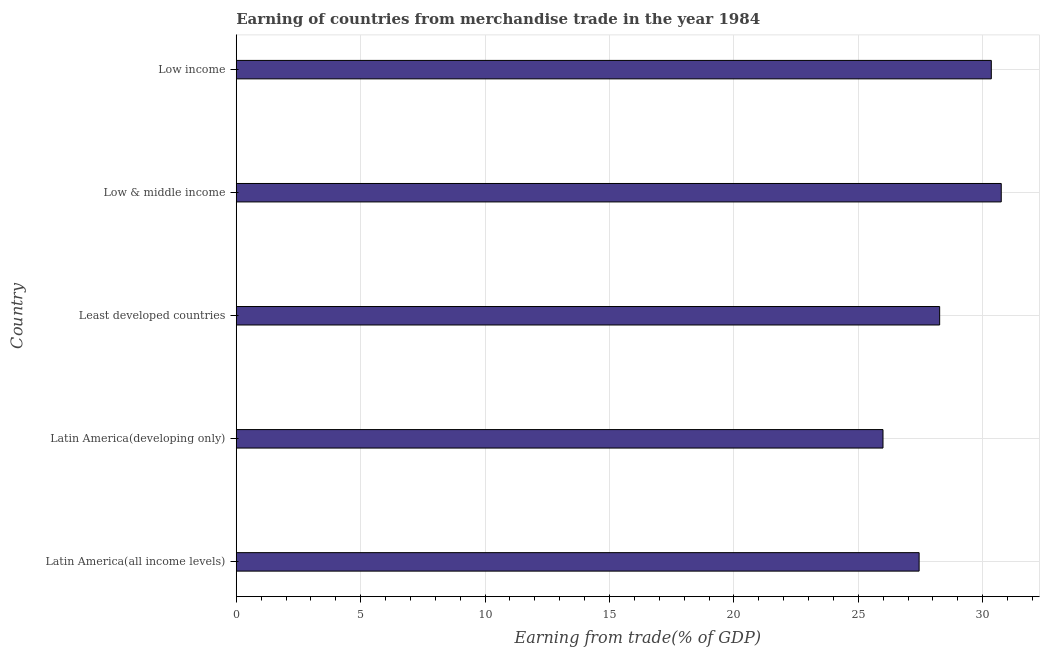What is the title of the graph?
Offer a terse response. Earning of countries from merchandise trade in the year 1984. What is the label or title of the X-axis?
Provide a succinct answer. Earning from trade(% of GDP). What is the label or title of the Y-axis?
Provide a succinct answer. Country. What is the earning from merchandise trade in Least developed countries?
Provide a short and direct response. 28.27. Across all countries, what is the maximum earning from merchandise trade?
Provide a succinct answer. 30.74. Across all countries, what is the minimum earning from merchandise trade?
Your answer should be very brief. 25.99. In which country was the earning from merchandise trade maximum?
Make the answer very short. Low & middle income. In which country was the earning from merchandise trade minimum?
Ensure brevity in your answer.  Latin America(developing only). What is the sum of the earning from merchandise trade?
Provide a succinct answer. 142.79. What is the difference between the earning from merchandise trade in Latin America(all income levels) and Latin America(developing only)?
Make the answer very short. 1.45. What is the average earning from merchandise trade per country?
Your answer should be compact. 28.56. What is the median earning from merchandise trade?
Your answer should be very brief. 28.27. In how many countries, is the earning from merchandise trade greater than 18 %?
Your response must be concise. 5. What is the ratio of the earning from merchandise trade in Least developed countries to that in Low & middle income?
Give a very brief answer. 0.92. What is the difference between the highest and the second highest earning from merchandise trade?
Your answer should be compact. 0.4. What is the difference between the highest and the lowest earning from merchandise trade?
Your answer should be very brief. 4.75. How many countries are there in the graph?
Give a very brief answer. 5. What is the difference between two consecutive major ticks on the X-axis?
Offer a very short reply. 5. What is the Earning from trade(% of GDP) of Latin America(all income levels)?
Make the answer very short. 27.44. What is the Earning from trade(% of GDP) in Latin America(developing only)?
Give a very brief answer. 25.99. What is the Earning from trade(% of GDP) in Least developed countries?
Your response must be concise. 28.27. What is the Earning from trade(% of GDP) of Low & middle income?
Ensure brevity in your answer.  30.74. What is the Earning from trade(% of GDP) of Low income?
Provide a short and direct response. 30.34. What is the difference between the Earning from trade(% of GDP) in Latin America(all income levels) and Latin America(developing only)?
Keep it short and to the point. 1.45. What is the difference between the Earning from trade(% of GDP) in Latin America(all income levels) and Least developed countries?
Your answer should be compact. -0.82. What is the difference between the Earning from trade(% of GDP) in Latin America(all income levels) and Low & middle income?
Keep it short and to the point. -3.3. What is the difference between the Earning from trade(% of GDP) in Latin America(all income levels) and Low income?
Your answer should be compact. -2.9. What is the difference between the Earning from trade(% of GDP) in Latin America(developing only) and Least developed countries?
Offer a very short reply. -2.28. What is the difference between the Earning from trade(% of GDP) in Latin America(developing only) and Low & middle income?
Ensure brevity in your answer.  -4.75. What is the difference between the Earning from trade(% of GDP) in Latin America(developing only) and Low income?
Your response must be concise. -4.35. What is the difference between the Earning from trade(% of GDP) in Least developed countries and Low & middle income?
Give a very brief answer. -2.48. What is the difference between the Earning from trade(% of GDP) in Least developed countries and Low income?
Ensure brevity in your answer.  -2.08. What is the difference between the Earning from trade(% of GDP) in Low & middle income and Low income?
Offer a terse response. 0.4. What is the ratio of the Earning from trade(% of GDP) in Latin America(all income levels) to that in Latin America(developing only)?
Keep it short and to the point. 1.06. What is the ratio of the Earning from trade(% of GDP) in Latin America(all income levels) to that in Low & middle income?
Give a very brief answer. 0.89. What is the ratio of the Earning from trade(% of GDP) in Latin America(all income levels) to that in Low income?
Your answer should be very brief. 0.9. What is the ratio of the Earning from trade(% of GDP) in Latin America(developing only) to that in Least developed countries?
Offer a very short reply. 0.92. What is the ratio of the Earning from trade(% of GDP) in Latin America(developing only) to that in Low & middle income?
Provide a succinct answer. 0.84. What is the ratio of the Earning from trade(% of GDP) in Latin America(developing only) to that in Low income?
Ensure brevity in your answer.  0.86. What is the ratio of the Earning from trade(% of GDP) in Least developed countries to that in Low & middle income?
Keep it short and to the point. 0.92. What is the ratio of the Earning from trade(% of GDP) in Least developed countries to that in Low income?
Provide a short and direct response. 0.93. What is the ratio of the Earning from trade(% of GDP) in Low & middle income to that in Low income?
Offer a very short reply. 1.01. 